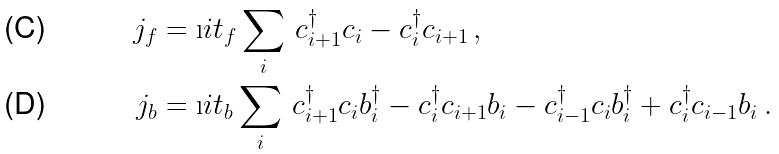Convert formula to latex. <formula><loc_0><loc_0><loc_500><loc_500>j _ { f } & = \i i t _ { f } \sum _ { i } \, c ^ { \dagger } _ { i + 1 } c _ { i } - c ^ { \dagger } _ { i } c _ { i + 1 } \, , \\ j _ { b } & = \i i t _ { b } \sum _ { i } \, c ^ { \dagger } _ { i + 1 } c _ { i } b ^ { \dagger } _ { i } - c ^ { \dagger } _ { i } c _ { i + 1 } b _ { i } - c ^ { \dagger } _ { i - 1 } c _ { i } b ^ { \dagger } _ { i } + c ^ { \dagger } _ { i } c _ { i - 1 } b _ { i } \, .</formula> 